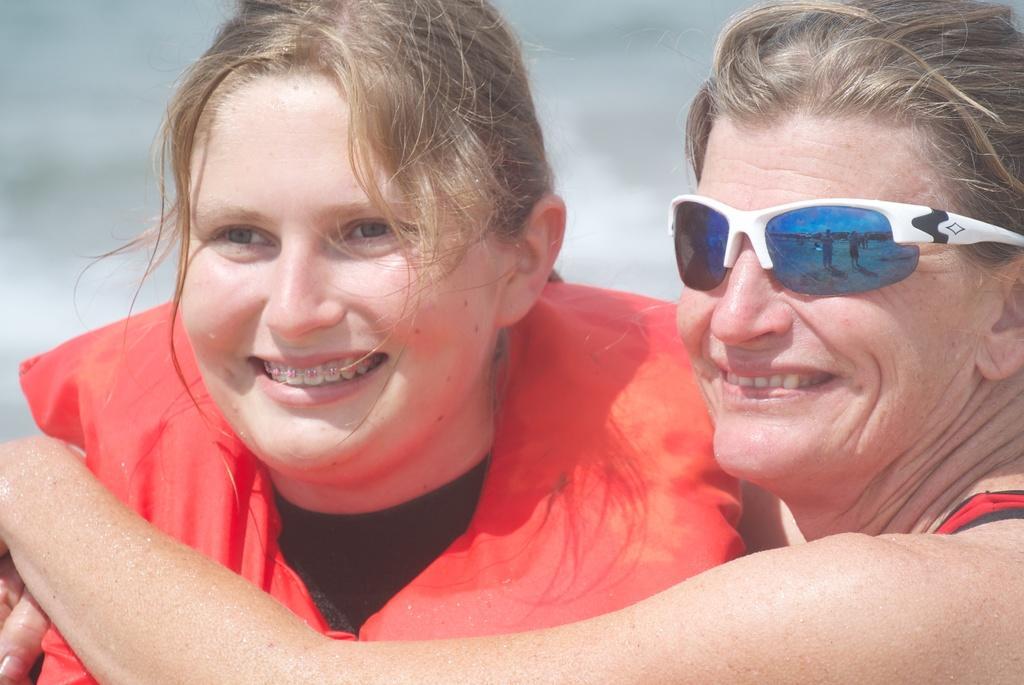Describe this image in one or two sentences. In this picture I can see couple of women and I can see a woman wearing sunglasses and I can see blurry background. 